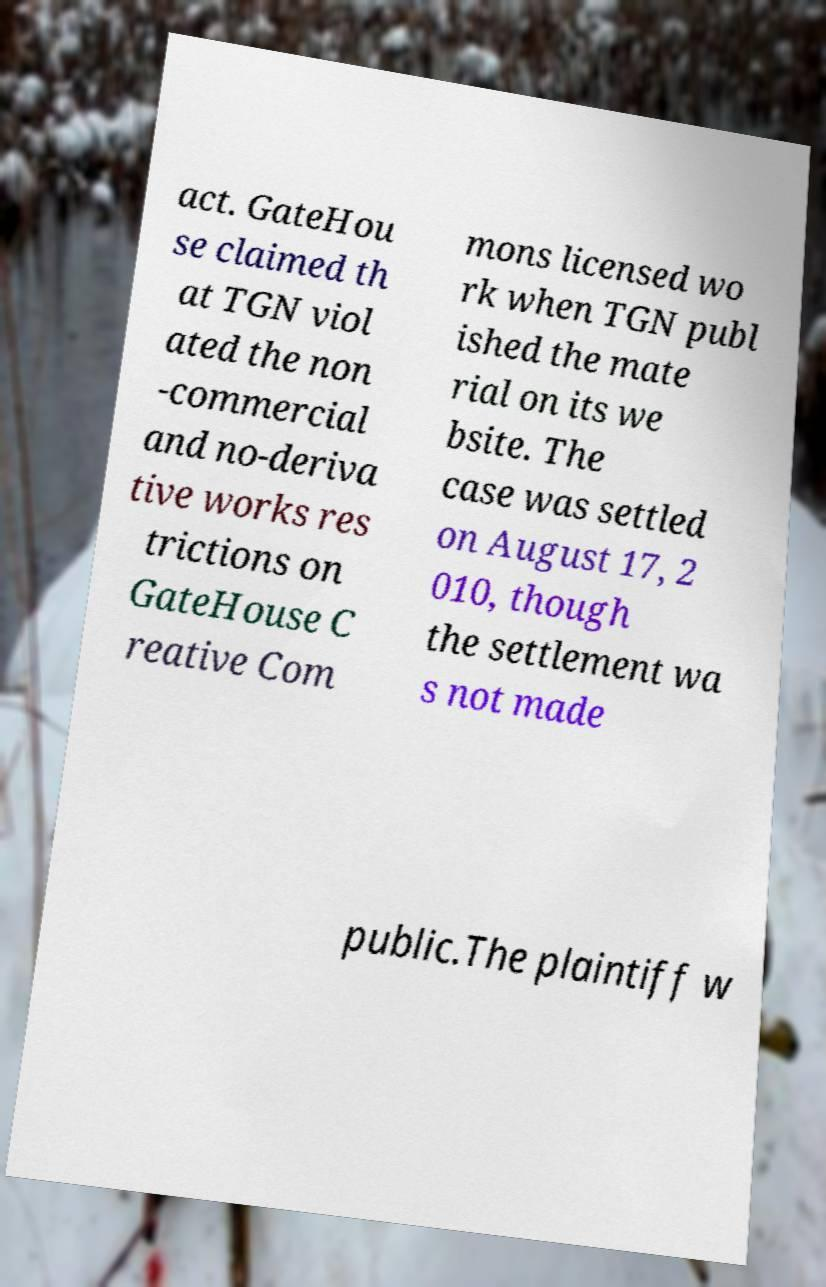There's text embedded in this image that I need extracted. Can you transcribe it verbatim? act. GateHou se claimed th at TGN viol ated the non -commercial and no-deriva tive works res trictions on GateHouse C reative Com mons licensed wo rk when TGN publ ished the mate rial on its we bsite. The case was settled on August 17, 2 010, though the settlement wa s not made public.The plaintiff w 